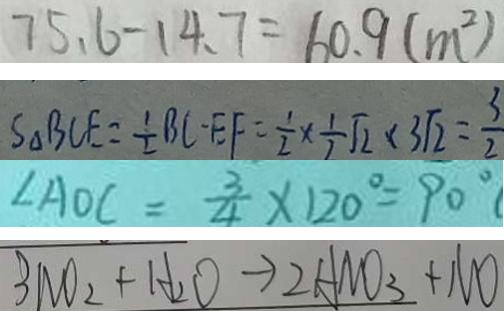<formula> <loc_0><loc_0><loc_500><loc_500>7 5 . 6 - 1 4 . 7 = 6 0 . 9 ( m ^ { 2 } ) 
 S _ { \Delta } B C E = \frac { 1 } { 2 } B C E F = \frac { 1 } { 2 } \times \frac { 1 } { 2 } \sqrt { 2 } \times 3 \sqrt { 2 } = \frac { 3 } { 2 } 
 \angle A O C = \frac { 3 } { 4 } \times 1 2 0 ^ { \circ } = 9 0 ^ { \circ } ( 
 3 N O _ { 2 } + H _ { 2 } O \rightarrow 2 A N O _ { 3 } + N O</formula> 